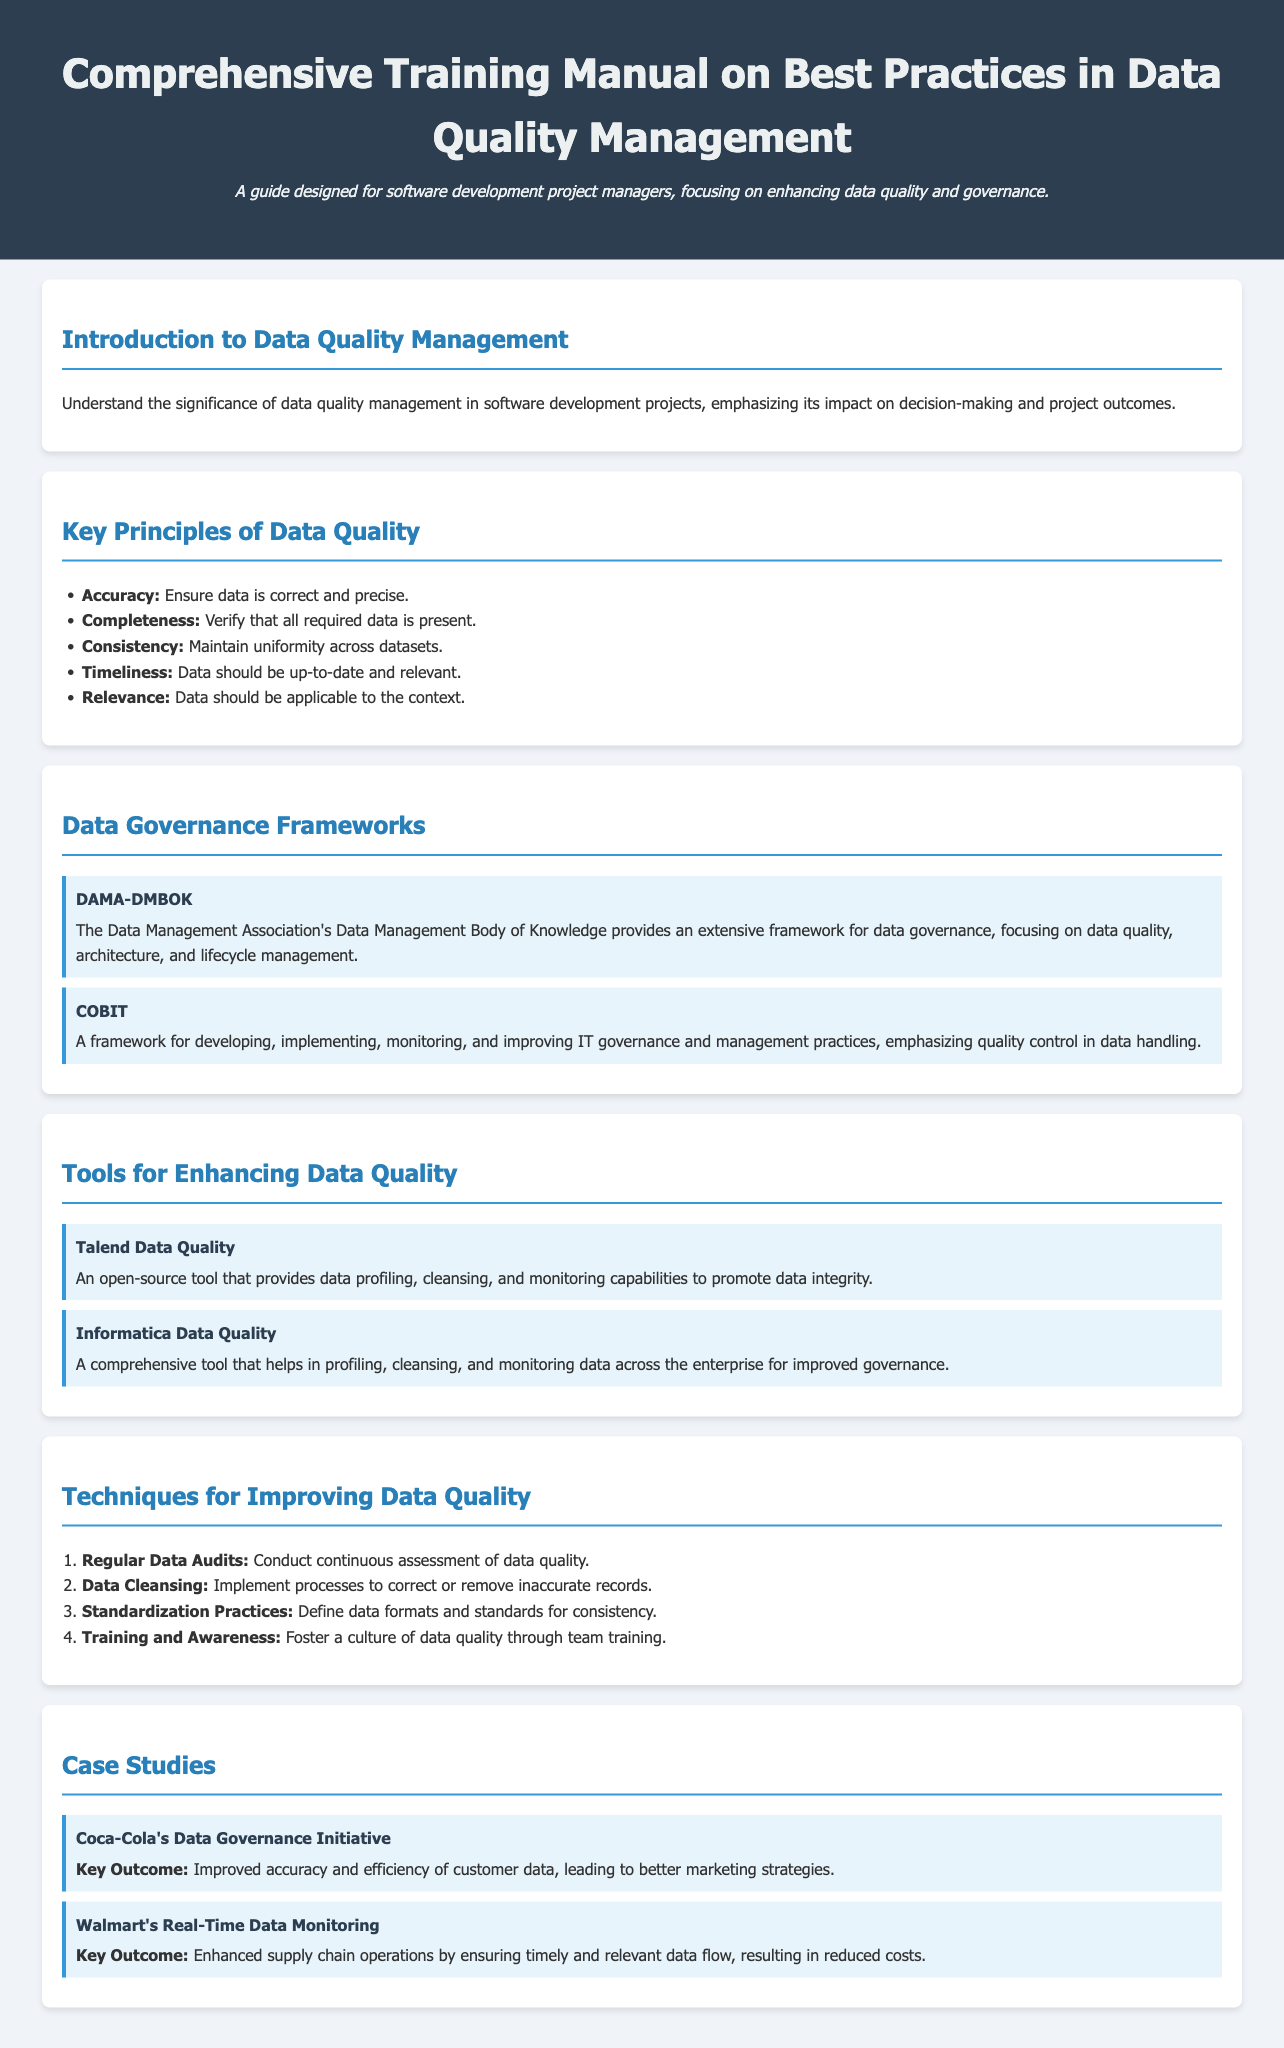What is the title of the document? The title is the main heading of the document, which is displayed at the top.
Answer: Comprehensive Training Manual on Best Practices in Data Quality Management What does DAMA-DMBOK stand for? DAMA-DMBOK is the acronym for the framework mentioned under Data Governance Frameworks.
Answer: Data Management Association's Data Management Body of Knowledge Which tool is an open-source data quality tool? The question refers to the specific characteristics of tools listed under Tools for Enhancing Data Quality.
Answer: Talend Data Quality How many key principles of data quality are listed? The count of items in the list under Key Principles of Data Quality gives the answer.
Answer: Five What was a key outcome of Coca-Cola's Data Governance Initiative? This outcome is stated clearly in the case study regarding Coca-Cola.
Answer: Improved accuracy and efficiency of customer data What framework emphasizes quality control in data handling? The inquiry specifies the framework designed for IT governance regarding data handling practices.
Answer: COBIT What technique involves correcting or removing inaccurate records? This technique is found in the Techniques for Improving Data Quality section.
Answer: Data Cleansing Which company enhanced supply chain operations through real-time data monitoring? The company name is mentioned in the Case Studies section regarding operational improvements.
Answer: Walmart 